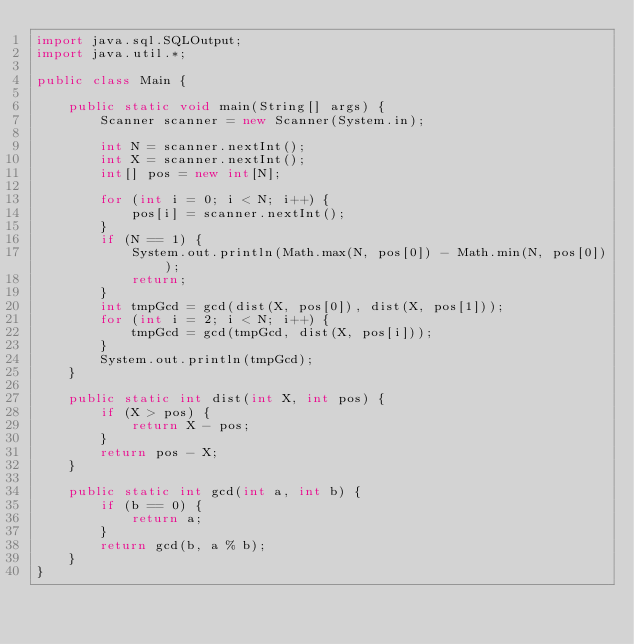Convert code to text. <code><loc_0><loc_0><loc_500><loc_500><_Java_>import java.sql.SQLOutput;
import java.util.*;

public class Main {

    public static void main(String[] args) {
        Scanner scanner = new Scanner(System.in);

        int N = scanner.nextInt();
        int X = scanner.nextInt();
        int[] pos = new int[N];

        for (int i = 0; i < N; i++) {
            pos[i] = scanner.nextInt();
        }
        if (N == 1) {
            System.out.println(Math.max(N, pos[0]) - Math.min(N, pos[0]));
            return;
        }
        int tmpGcd = gcd(dist(X, pos[0]), dist(X, pos[1]));
        for (int i = 2; i < N; i++) {
            tmpGcd = gcd(tmpGcd, dist(X, pos[i]));
        }
        System.out.println(tmpGcd);
    }

    public static int dist(int X, int pos) {
        if (X > pos) {
            return X - pos;
        }
        return pos - X;
    }

    public static int gcd(int a, int b) {
        if (b == 0) {
            return a;
        }
        return gcd(b, a % b);
    }
}</code> 